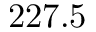Convert formula to latex. <formula><loc_0><loc_0><loc_500><loc_500>2 2 7 . 5</formula> 